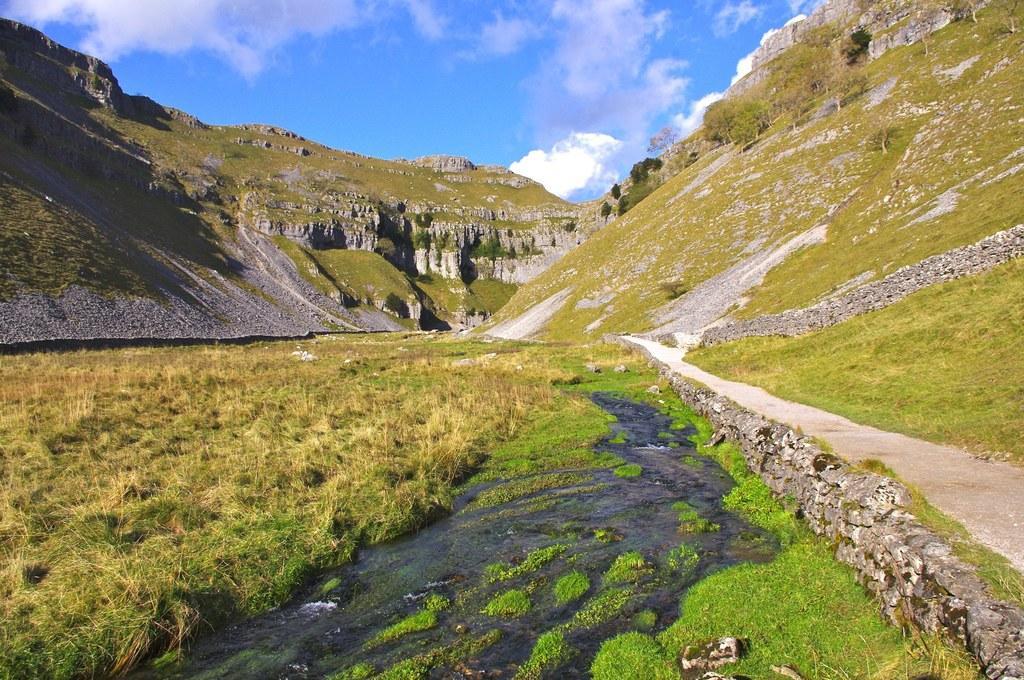How would you summarize this image in a sentence or two? In this image, we can see some grass, water. We can also see the ground. There are a few hills. We can see the sky with clouds. 